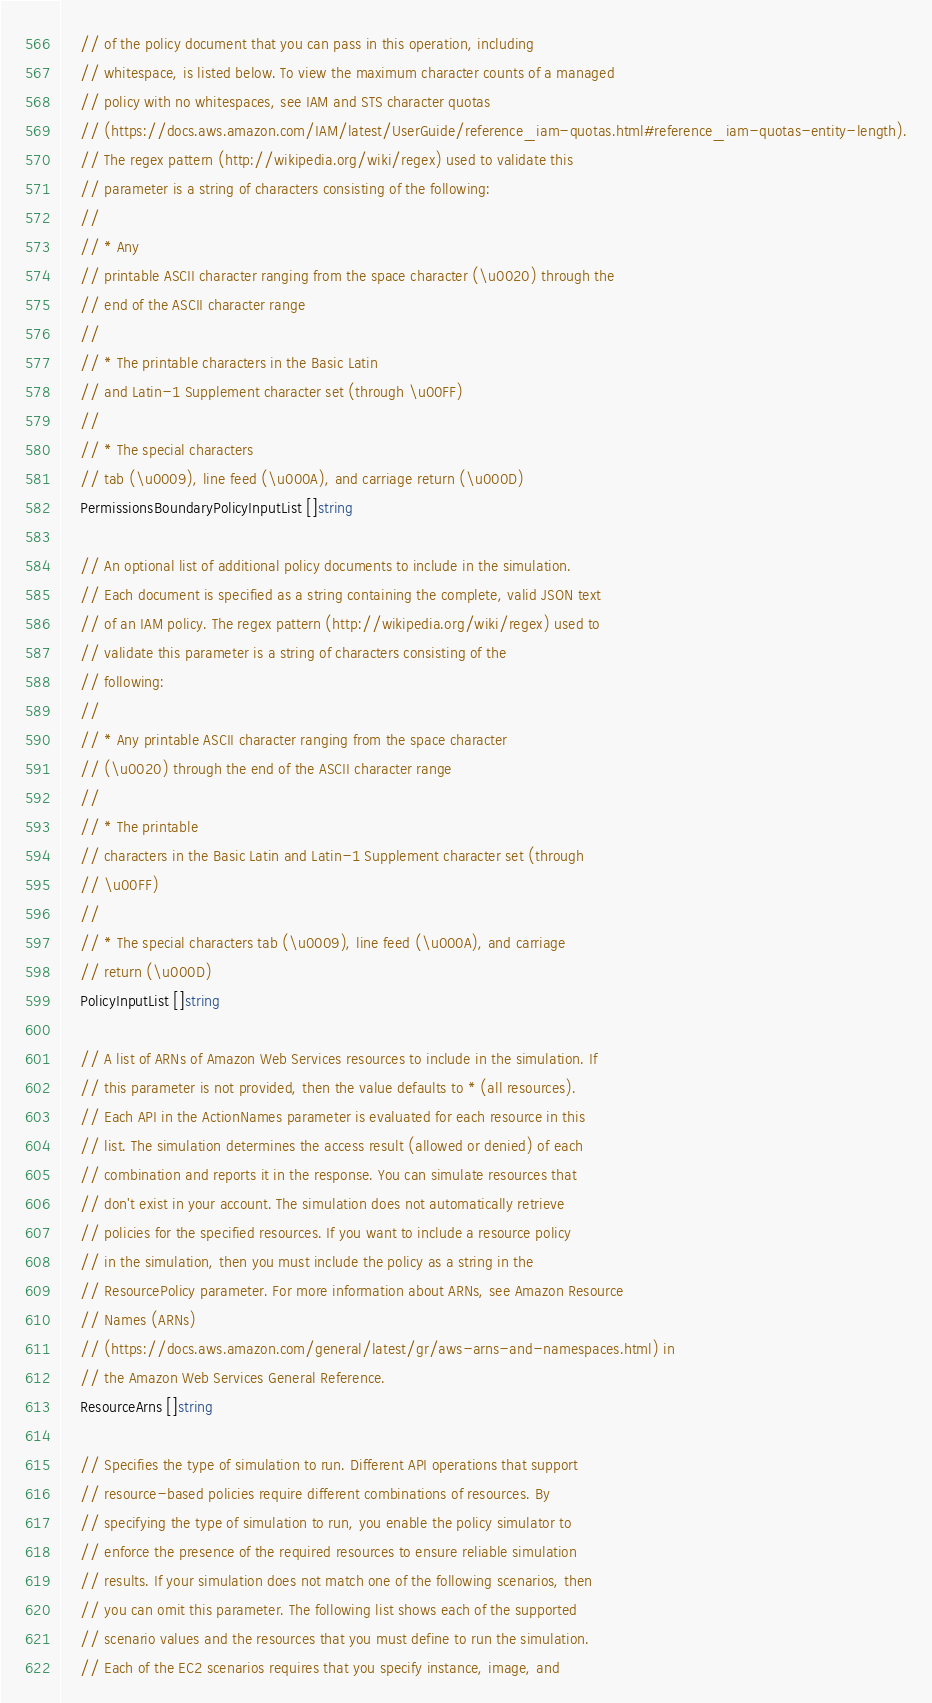Convert code to text. <code><loc_0><loc_0><loc_500><loc_500><_Go_>	// of the policy document that you can pass in this operation, including
	// whitespace, is listed below. To view the maximum character counts of a managed
	// policy with no whitespaces, see IAM and STS character quotas
	// (https://docs.aws.amazon.com/IAM/latest/UserGuide/reference_iam-quotas.html#reference_iam-quotas-entity-length).
	// The regex pattern (http://wikipedia.org/wiki/regex) used to validate this
	// parameter is a string of characters consisting of the following:
	//
	// * Any
	// printable ASCII character ranging from the space character (\u0020) through the
	// end of the ASCII character range
	//
	// * The printable characters in the Basic Latin
	// and Latin-1 Supplement character set (through \u00FF)
	//
	// * The special characters
	// tab (\u0009), line feed (\u000A), and carriage return (\u000D)
	PermissionsBoundaryPolicyInputList []string

	// An optional list of additional policy documents to include in the simulation.
	// Each document is specified as a string containing the complete, valid JSON text
	// of an IAM policy. The regex pattern (http://wikipedia.org/wiki/regex) used to
	// validate this parameter is a string of characters consisting of the
	// following:
	//
	// * Any printable ASCII character ranging from the space character
	// (\u0020) through the end of the ASCII character range
	//
	// * The printable
	// characters in the Basic Latin and Latin-1 Supplement character set (through
	// \u00FF)
	//
	// * The special characters tab (\u0009), line feed (\u000A), and carriage
	// return (\u000D)
	PolicyInputList []string

	// A list of ARNs of Amazon Web Services resources to include in the simulation. If
	// this parameter is not provided, then the value defaults to * (all resources).
	// Each API in the ActionNames parameter is evaluated for each resource in this
	// list. The simulation determines the access result (allowed or denied) of each
	// combination and reports it in the response. You can simulate resources that
	// don't exist in your account. The simulation does not automatically retrieve
	// policies for the specified resources. If you want to include a resource policy
	// in the simulation, then you must include the policy as a string in the
	// ResourcePolicy parameter. For more information about ARNs, see Amazon Resource
	// Names (ARNs)
	// (https://docs.aws.amazon.com/general/latest/gr/aws-arns-and-namespaces.html) in
	// the Amazon Web Services General Reference.
	ResourceArns []string

	// Specifies the type of simulation to run. Different API operations that support
	// resource-based policies require different combinations of resources. By
	// specifying the type of simulation to run, you enable the policy simulator to
	// enforce the presence of the required resources to ensure reliable simulation
	// results. If your simulation does not match one of the following scenarios, then
	// you can omit this parameter. The following list shows each of the supported
	// scenario values and the resources that you must define to run the simulation.
	// Each of the EC2 scenarios requires that you specify instance, image, and</code> 